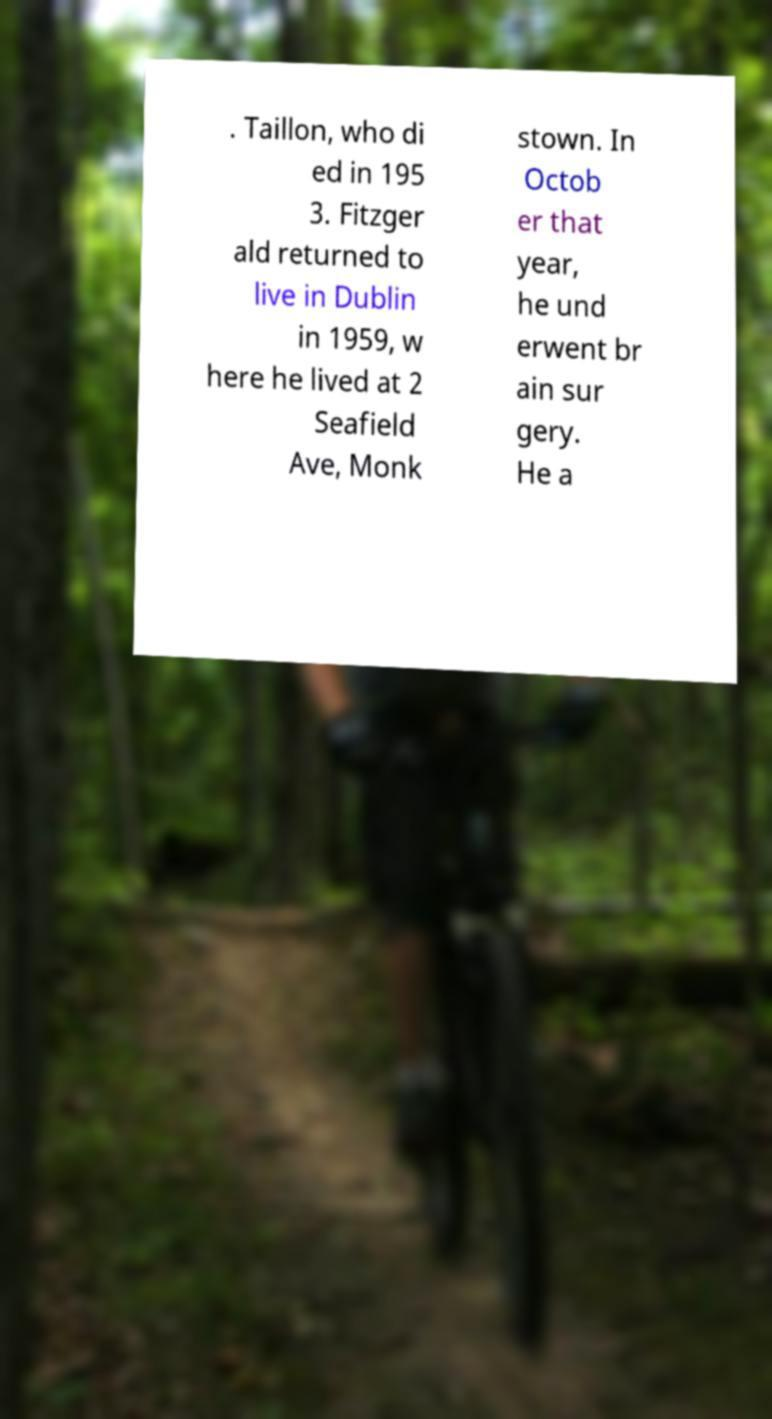Can you accurately transcribe the text from the provided image for me? . Taillon, who di ed in 195 3. Fitzger ald returned to live in Dublin in 1959, w here he lived at 2 Seafield Ave, Monk stown. In Octob er that year, he und erwent br ain sur gery. He a 